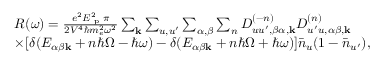<formula> <loc_0><loc_0><loc_500><loc_500>\begin{array} { r l } & { R ( \omega ) = \frac { e ^ { 2 } E _ { p } ^ { 2 } \pi } { 2 V ^ { 4 } \hbar { m } _ { e } ^ { 2 } \omega ^ { 2 } } \sum _ { k } \sum _ { u , u ^ { \prime } } \sum _ { \alpha , \beta } \sum _ { n } D _ { u u ^ { \prime } , \beta \alpha , k } ^ { ( - n ) } D _ { u ^ { \prime } u , \alpha \beta , k } ^ { ( n ) } } \\ & { \times [ \delta ( E _ { \alpha \beta k } + n \hbar { \Omega } - \hbar { \omega } ) - \delta ( E _ { \alpha \beta k } + n \hbar { \Omega } + \hbar { \omega } ) ] \bar { n } _ { u } ( 1 - \bar { n } _ { u ^ { \prime } } ) , } \end{array}</formula> 